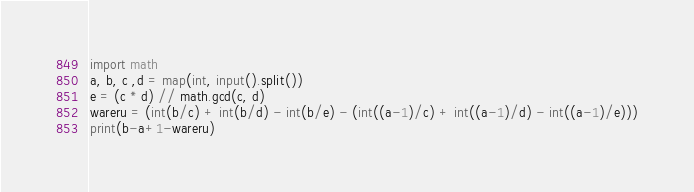Convert code to text. <code><loc_0><loc_0><loc_500><loc_500><_Python_>import math
a, b, c ,d = map(int, input().split())
e = (c * d) // math.gcd(c, d)
wareru = (int(b/c) + int(b/d) - int(b/e) - (int((a-1)/c) + int((a-1)/d) - int((a-1)/e)))
print(b-a+1-wareru)</code> 